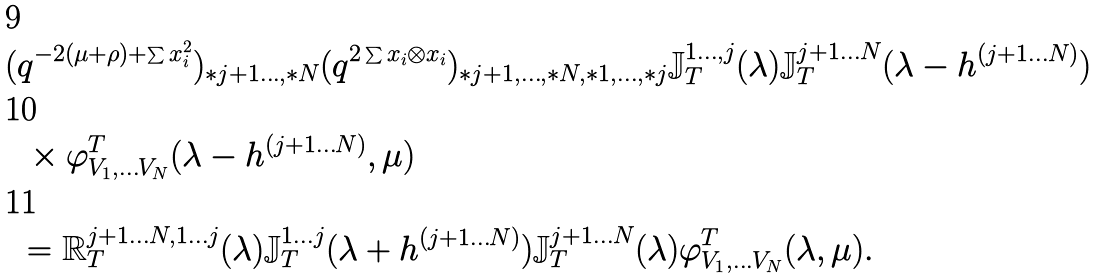Convert formula to latex. <formula><loc_0><loc_0><loc_500><loc_500>( & q ^ { - 2 ( \mu + \rho ) + \sum x _ { i } ^ { 2 } } ) _ { * j + 1 \dots , * N } ( q ^ { 2 \sum x _ { i } \otimes x _ { i } } ) _ { * j + 1 , \dots , * N , * 1 , \dots , * j } \mathbb { J } _ { T } ^ { 1 \dots , j } ( \lambda ) \mathbb { J } _ { T } ^ { j + 1 \dots N } ( \lambda - h ^ { ( j + 1 \dots N ) } ) \\ & \, \times \varphi ^ { T } _ { V _ { 1 } , \dots V _ { N } } ( \lambda - h ^ { ( j + 1 \dots N ) } , \mu ) \\ & = \mathbb { R } _ { T } ^ { j + 1 \dots N , 1 \dots j } ( \lambda ) \mathbb { J } _ { T } ^ { 1 \dots j } ( \lambda + h ^ { ( j + 1 \dots N ) } ) \mathbb { J } _ { T } ^ { j + 1 \dots N } ( \lambda ) \varphi ^ { T } _ { V _ { 1 } , \dots V _ { N } } ( \lambda , \mu ) .</formula> 